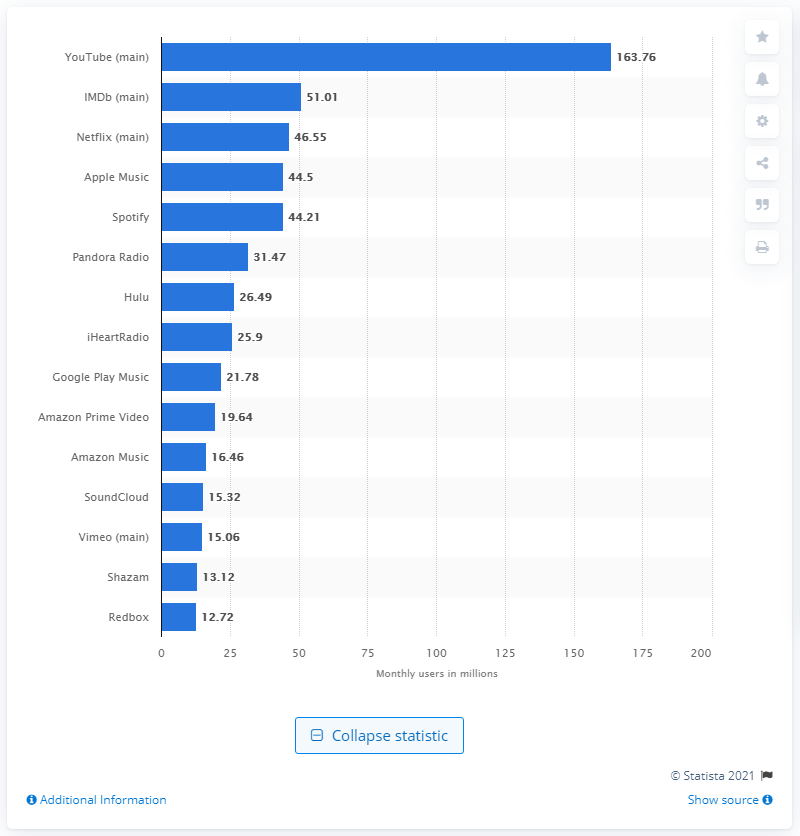Highlight a few significant elements in this photo. In September 2019, a total of 163.76 mobile users accessed the YouTube app. 